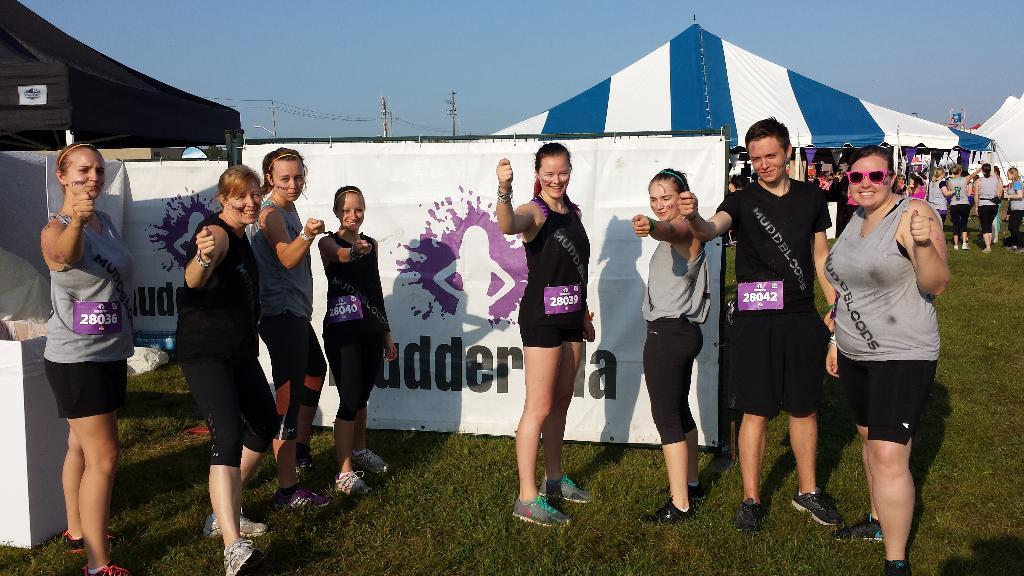What is the main subject of the image? The main subject of the image is a group of women. What are the women doing in the image? The women are standing and posing for the camera. Can you describe the background of the image? The background has a white color poster and a blue and white color tint. What type of nail is being hammered into the poster in the image? There is no nail being hammered into the poster in the image; it only features a white color poster in the background. 